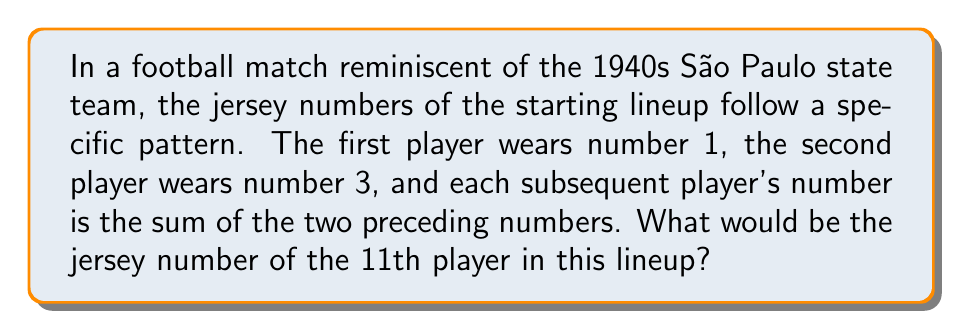Give your solution to this math problem. Let's break this down step-by-step:

1) We start with the first two numbers in the sequence: 1 and 3.

2) Each subsequent number is the sum of the two preceding numbers. This forms a Fibonacci-like sequence.

3) Let's calculate the first 11 numbers in the sequence:

   1st player: 1
   2nd player: 3
   3rd player: 1 + 3 = 4
   4th player: 3 + 4 = 7
   5th player: 4 + 7 = 11
   6th player: 7 + 11 = 18
   7th player: 11 + 18 = 29
   8th player: 18 + 29 = 47
   9th player: 29 + 47 = 76
   10th player: 47 + 76 = 123
   11th player: 76 + 123 = 199

4) We can express this mathematically as a recurrence relation:

   $$a_n = a_{n-1} + a_{n-2}$$

   Where $a_1 = 1$, $a_2 = 3$, and $n \geq 3$

5) Therefore, the 11th number in the sequence, which corresponds to the jersey number of the 11th player, is 199.
Answer: 199 